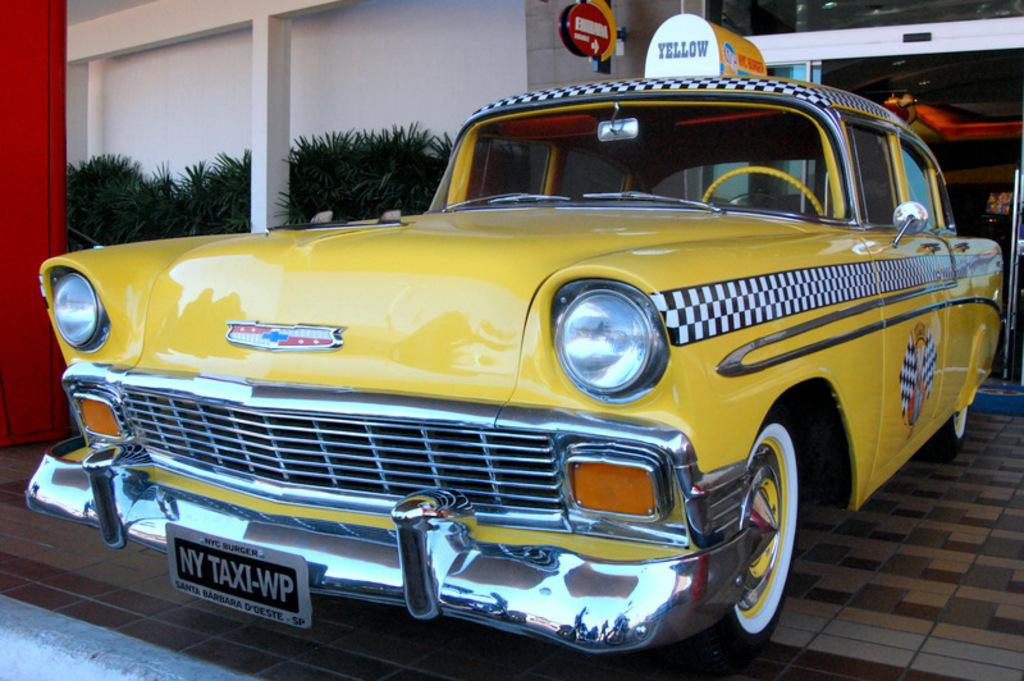<image>
Offer a succinct explanation of the picture presented. An old fashioned yellow taxi has a sign that says Yellow on top. 